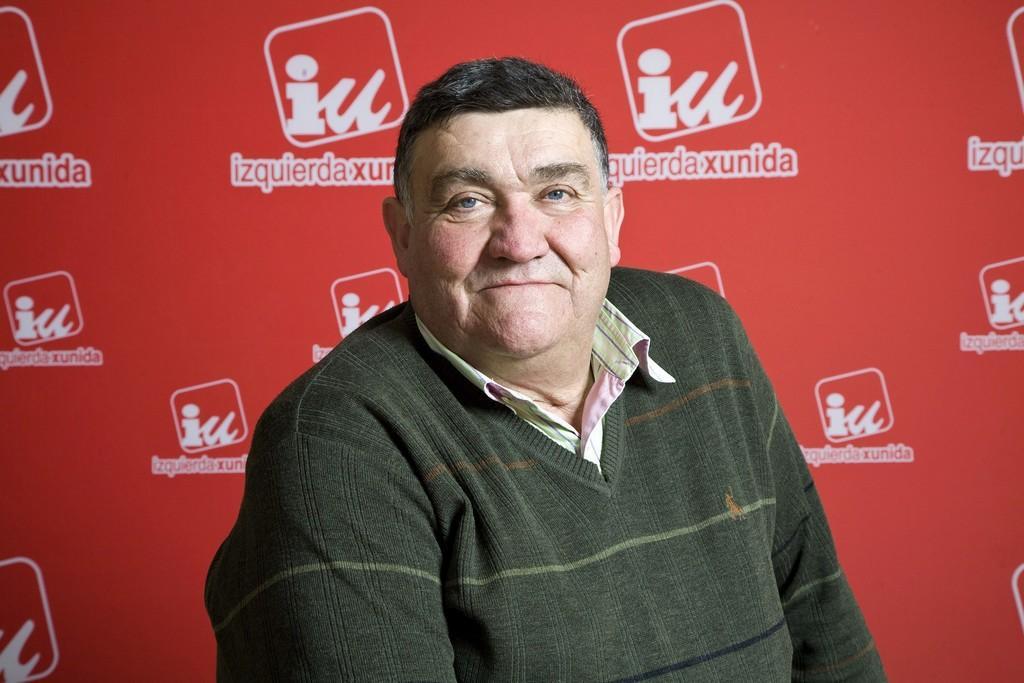Could you give a brief overview of what you see in this image? In this image there is a man sitting on a chair, in the background there is a banner, on that banner there is some text and a logo. 